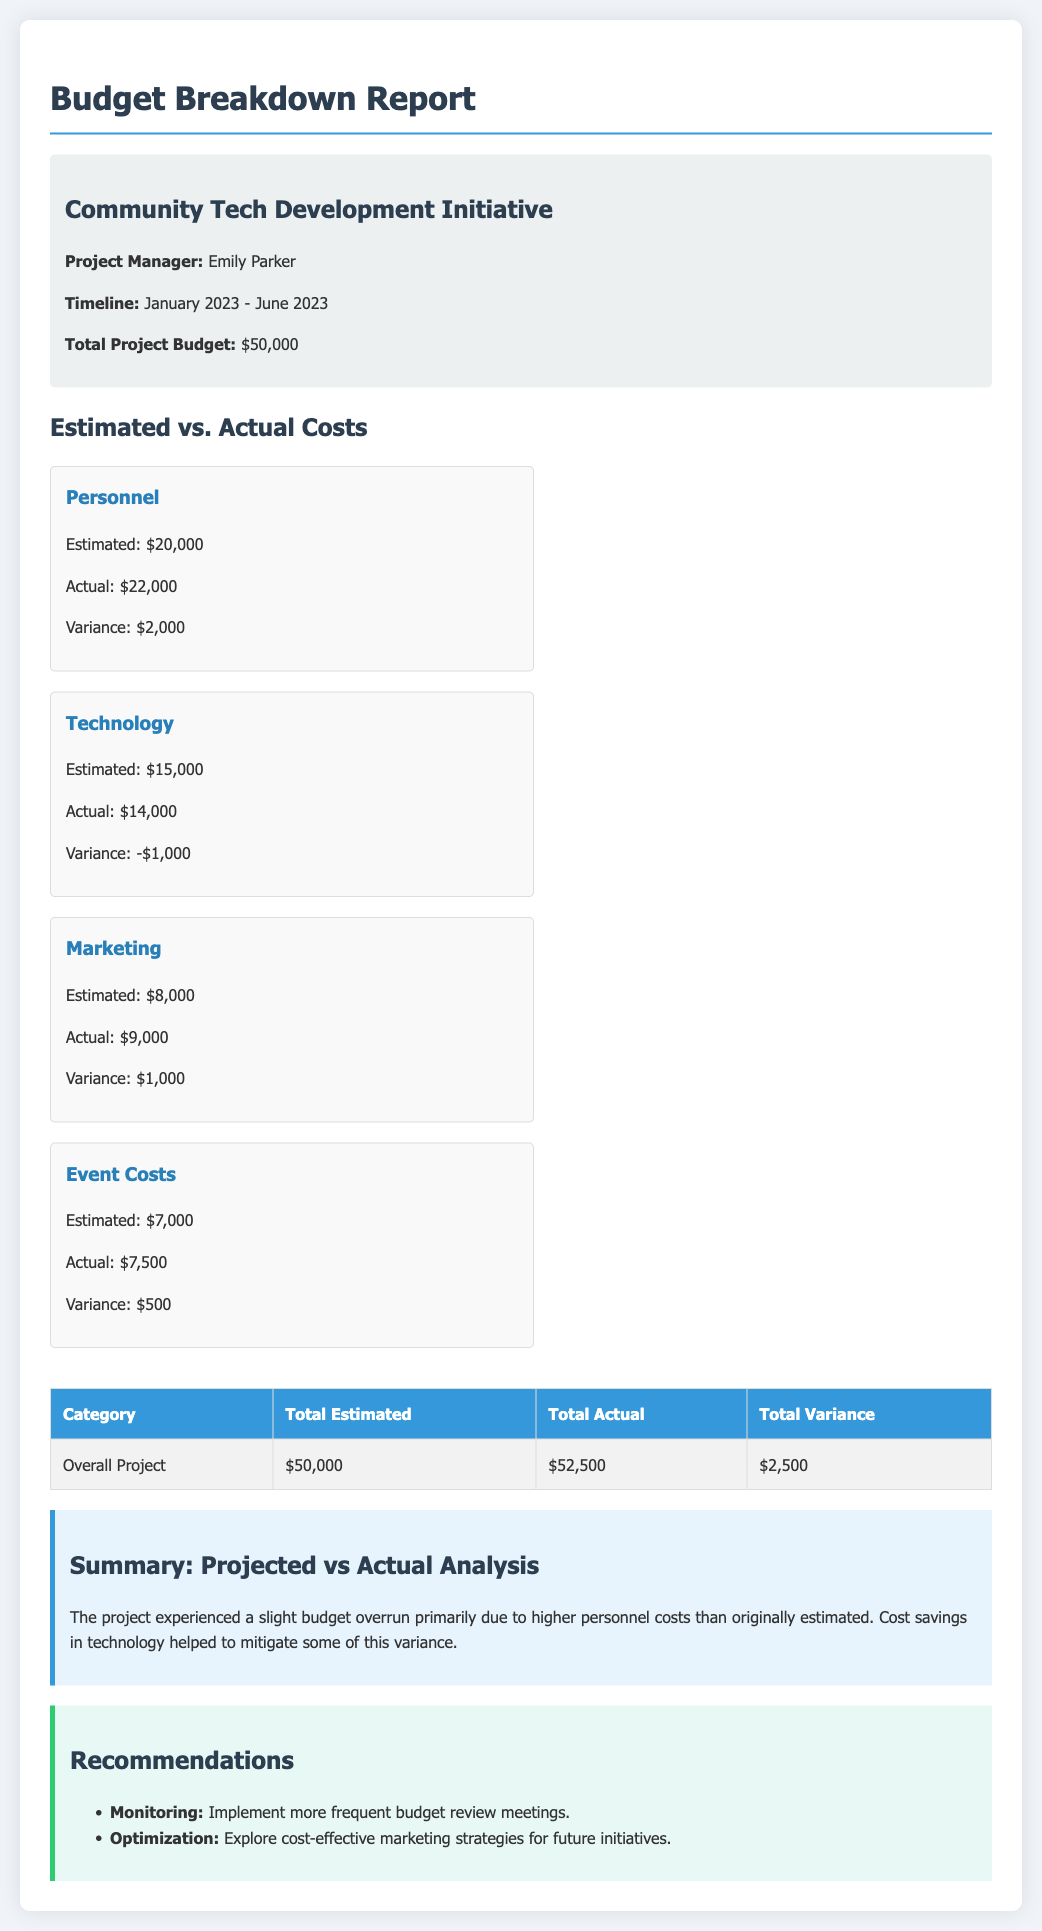What is the project manager's name? The project manager's name is mentioned in the project info section of the document.
Answer: Emily Parker What is the total project budget? The total project budget is stated directly in the document.
Answer: $50,000 What were the estimated costs for Technology? The estimated costs for Technology can be found in the cost breakdown section.
Answer: $15,000 What is the actual cost for Personnel? The actual cost for Personnel is listed in the costs breakdown section.
Answer: $22,000 What is the total variance for the overall project? The total variance for the overall project is found in the summary table.
Answer: $2,500 Which category experienced a cost savings? This category is identified in the summary analysis of the document.
Answer: Technology What is recommended for future initiatives regarding marketing? This recommendation is given in the recommendations section of the document.
Answer: Explore cost-effective marketing strategies What is the project timeline? The project timeline is provided in the project info section.
Answer: January 2023 - June 2023 